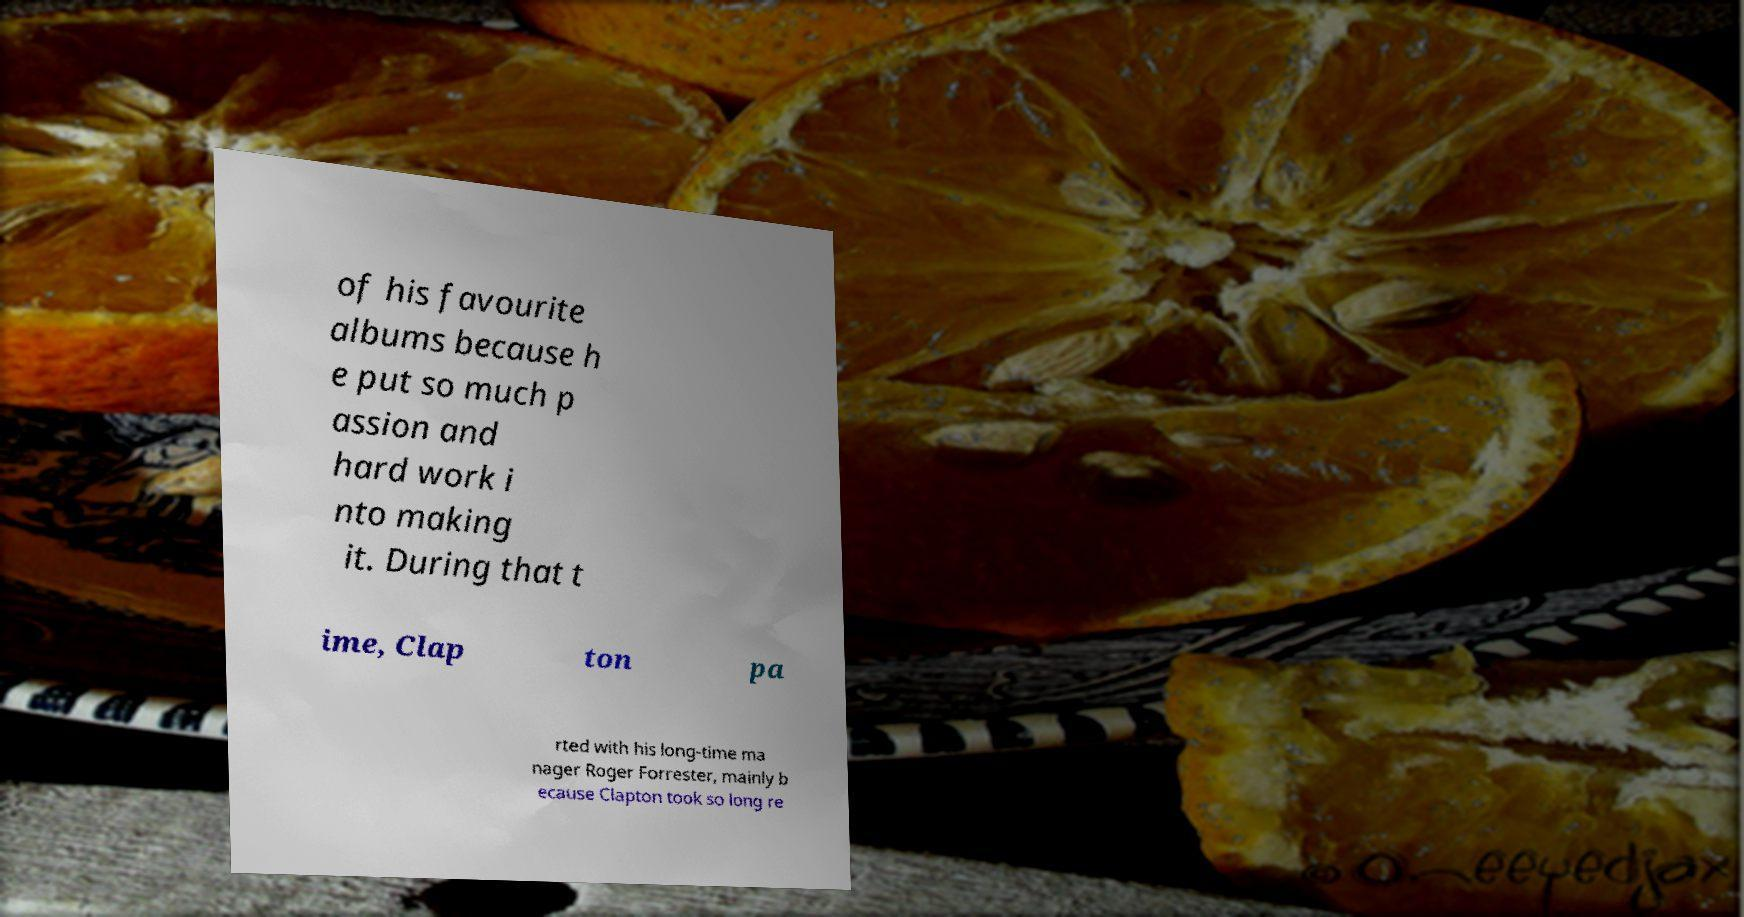Could you extract and type out the text from this image? of his favourite albums because h e put so much p assion and hard work i nto making it. During that t ime, Clap ton pa rted with his long-time ma nager Roger Forrester, mainly b ecause Clapton took so long re 